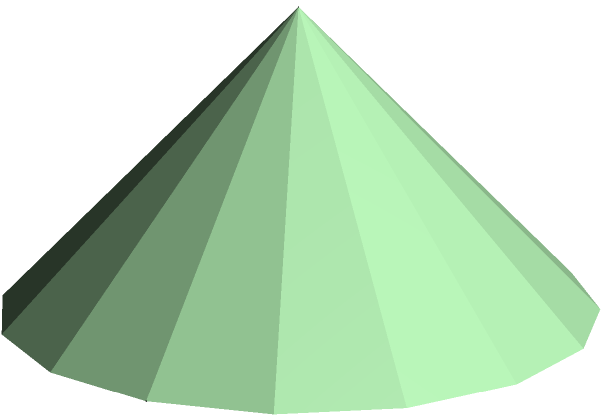While hiking on the Big Island of Hawaii, you come across a perfectly conical volcanic cinder cone. You estimate its height to be 100 meters and its base radius to be 150 meters. What is the volume of this volcanic cone in cubic meters? To calculate the volume of a cone, we can use the formula:

$$V = \frac{1}{3}\pi r^2 h$$

Where:
$V$ = volume of the cone
$r$ = radius of the base
$h$ = height of the cone

Given:
$h = 100$ meters
$r = 150$ meters

Let's substitute these values into the formula:

$$V = \frac{1}{3}\pi (150\text{ m})^2 (100\text{ m})$$

Now, let's calculate step by step:

1) First, calculate $r^2$:
   $150^2 = 22,500$

2) Multiply by $\pi$:
   $22,500\pi$

3) Multiply by the height:
   $22,500\pi \times 100 = 2,250,000\pi$

4) Divide by 3:
   $\frac{2,250,000\pi}{3} = 750,000\pi$

Therefore, the volume of the volcanic cone is $750,000\pi$ cubic meters.

To get a decimal approximation:
$750,000\pi \approx 2,356,194.5$ cubic meters
Answer: $750,000\pi$ cubic meters (or approximately 2,356,194.5 cubic meters) 